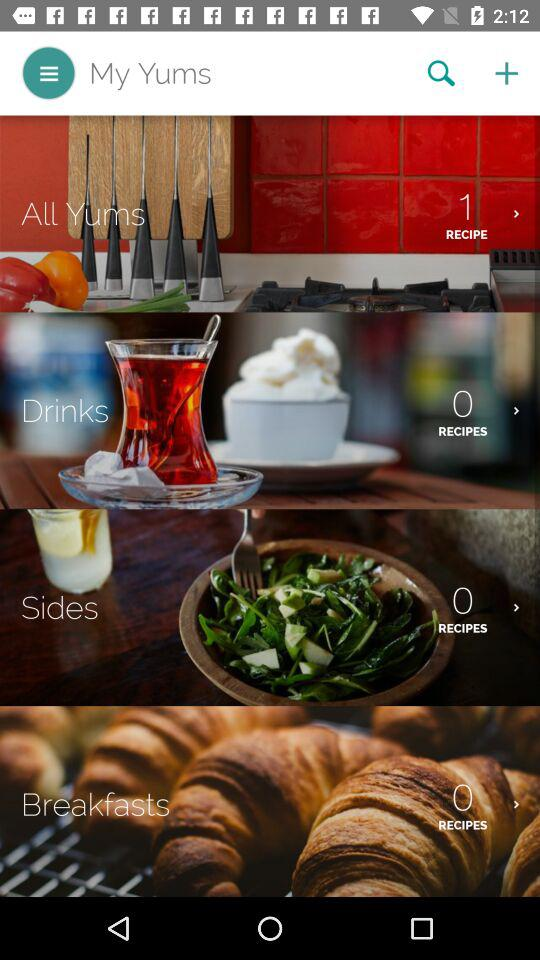How many recipes are in "Drinks"? There are 0 recipes. 